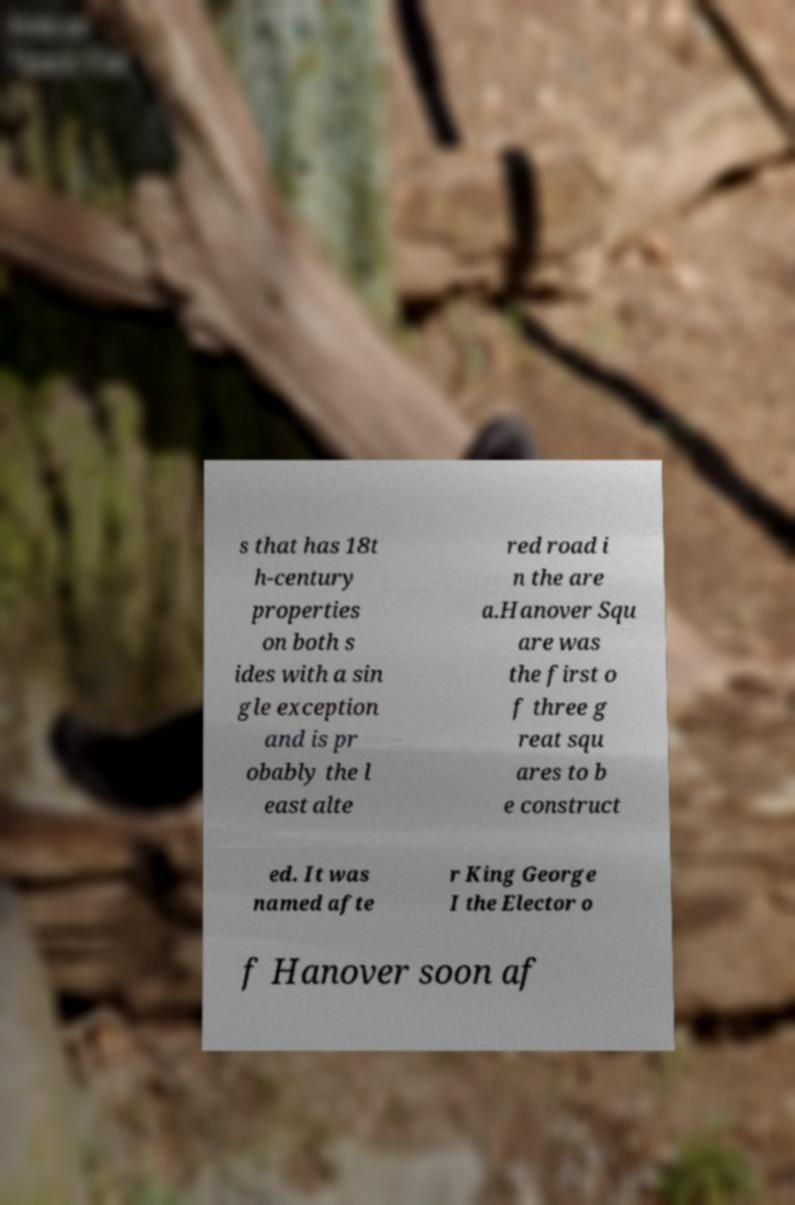For documentation purposes, I need the text within this image transcribed. Could you provide that? s that has 18t h-century properties on both s ides with a sin gle exception and is pr obably the l east alte red road i n the are a.Hanover Squ are was the first o f three g reat squ ares to b e construct ed. It was named afte r King George I the Elector o f Hanover soon af 